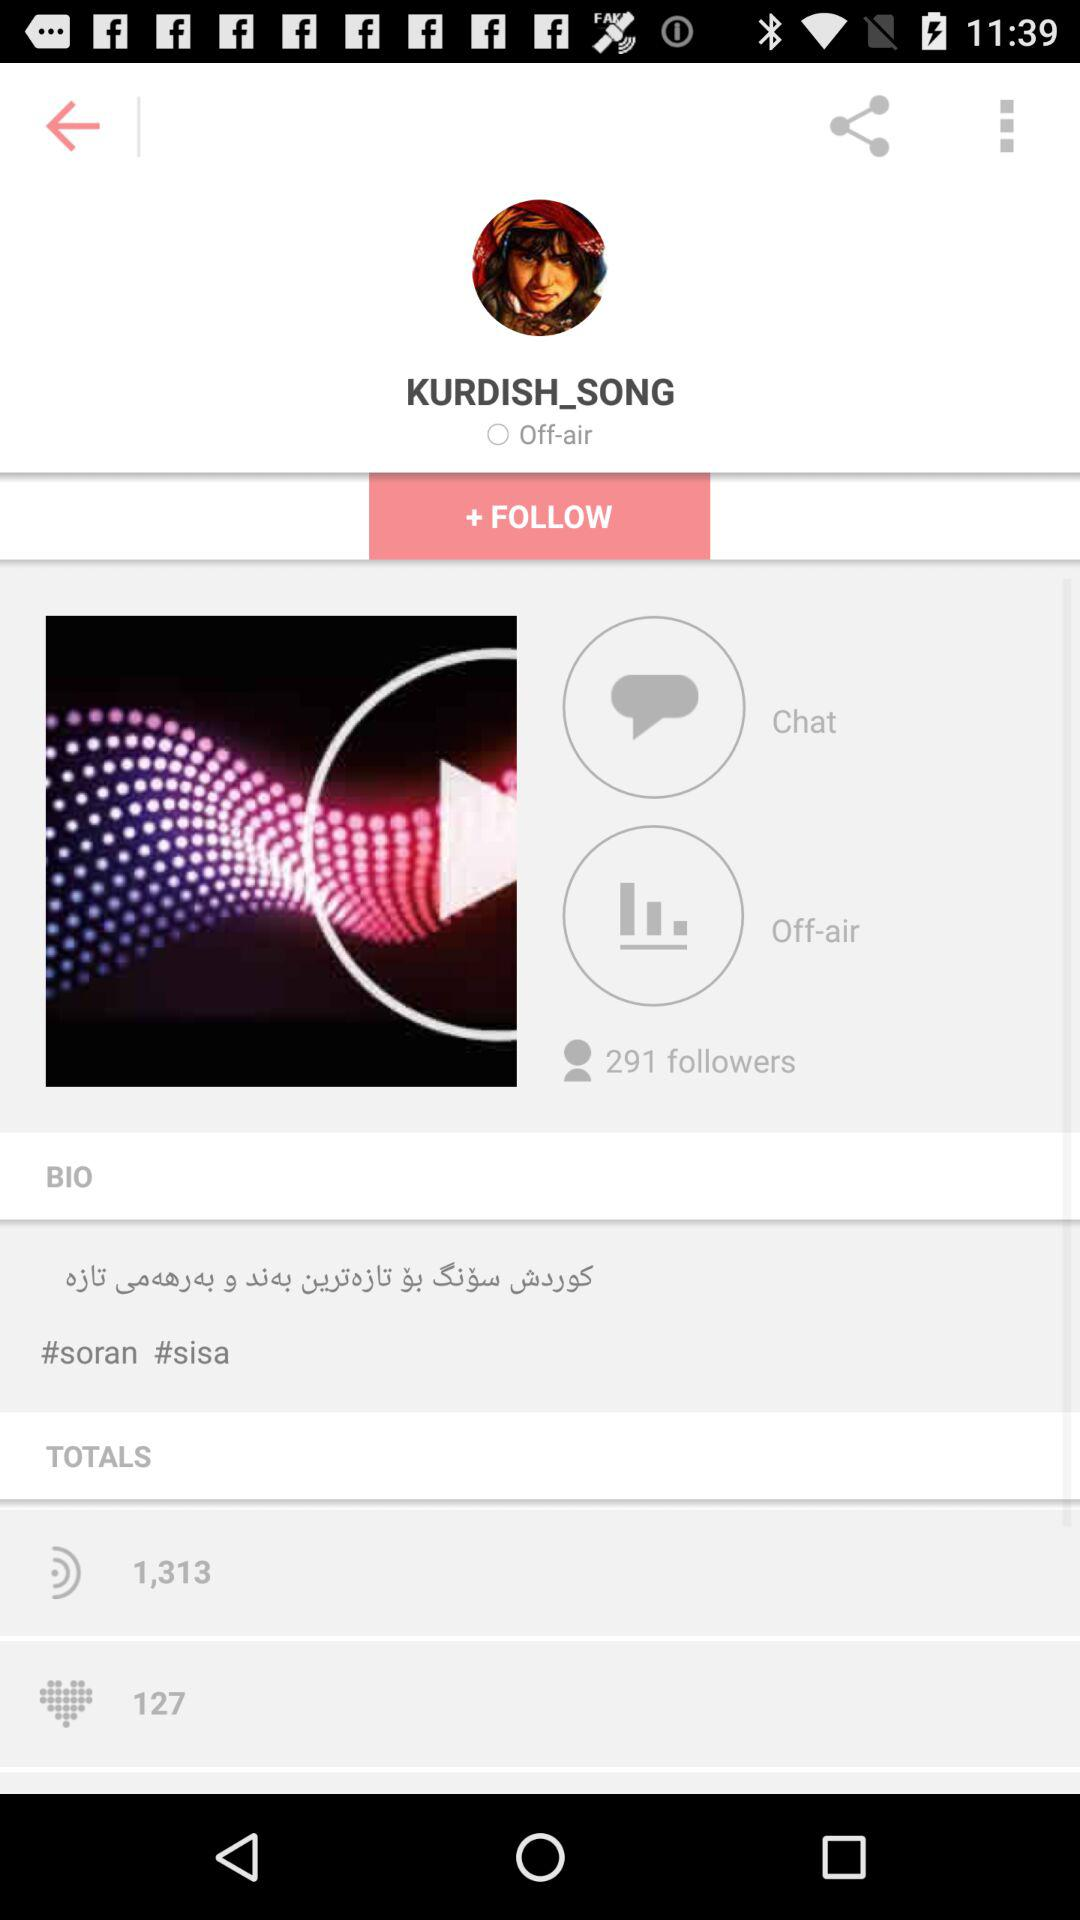What is the name of the song?
When the provided information is insufficient, respond with <no answer>. <no answer> 